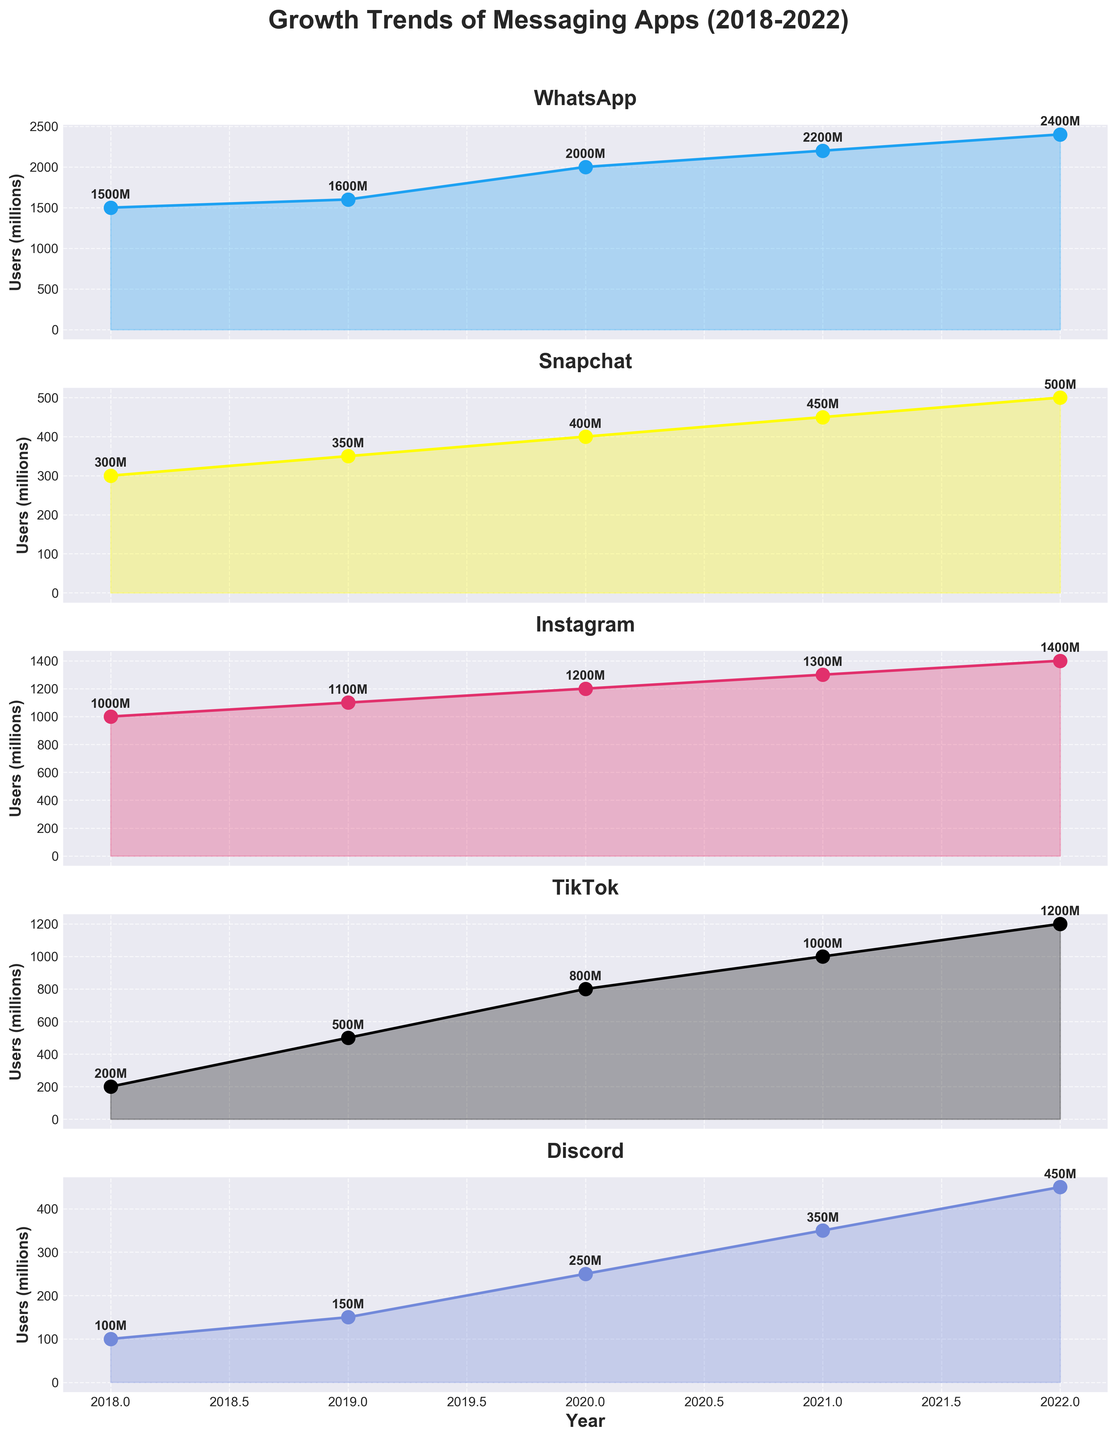What year is represented on the x-axis? The x-axis in the figure represents the years. Each subplot covers the same range of years from 2018 to 2022.
Answer: 2018 to 2022 Which app had the highest number of users in 2022? By looking at the highest data point across the subplots for the year 2022, WhatsApp had 2400 million users, which is the highest.
Answer: WhatsApp What color represents TikTok in the plots? Each subplot is color-coded, and TikTok is represented with a black line and markers.
Answer: Black What is the difference in the number of users between Snapchat and Discord in 2021? In 2021, Snapchat had 450 million users and Discord had 350 million users. The difference is 450 - 350 = 100 million users.
Answer: 100 million Which app experienced the largest increase in users from 2020 to 2021? By comparing the increase in users for each app from 2020 to 2021, WhatsApp went from 2000 to 2200 million users, a 200 million increase, which is the largest.
Answer: WhatsApp What is the combined total of Instagram users from 2018 to 2022? Sum the values for Instagram over the given years: 1000 + 1100 + 1200 + 1300 + 1400 = 6000 million users.
Answer: 6000 million How does Snapchat's growth trend compare to Discord's from 2018 to 2022? Both Snapchat and Discord show an upward trend, but Snapchat's user base grows from 300 to 500 million, while Discord grows from 100 to 450 million. Snapchat's growth is steadier, whereas Discord shows a sharper increase.
Answer: Steady for Snapchat, Sharper increase for Discord Which app had the smallest number of users in 2018? By checking the user numbers in 2018 for all apps, Discord had 100 million users, which is the smallest.
Answer: Discord Did any app surpass WhatsApp in any year? By observing the plots, no app surpassed WhatsApp's user numbers in any of the years from 2018 to 2022.
Answer: No 